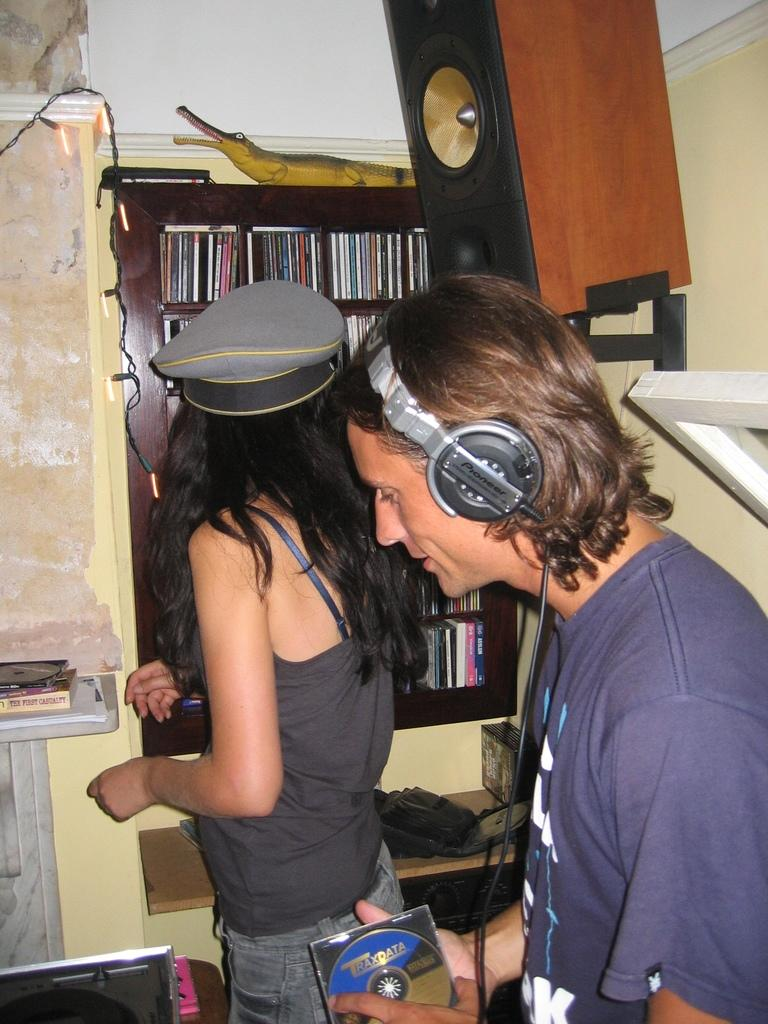How many people are in the image? There are two persons in the image. What are the two persons doing? The two persons are listening to music. What can be seen on the rack in the image? There are CDs and a crocodile toy on the rack. What device is used to play music in the image? There is a music player in the image. What is used to amplify the sound of the music in the image? There is a speaker in the image. What type of dock can be seen in the image? There is no dock present in the image. How many bags are visible in the image? There are no bags visible in the image. 